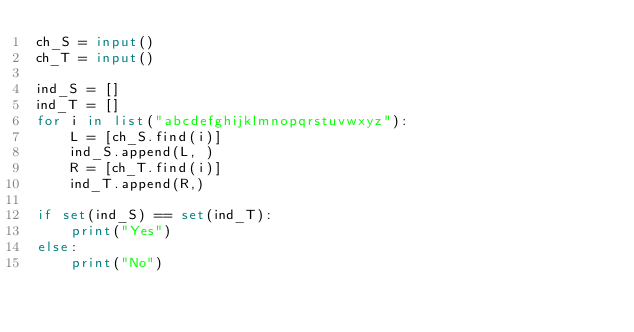Convert code to text. <code><loc_0><loc_0><loc_500><loc_500><_Python_>ch_S = input()
ch_T = input()

ind_S = []
ind_T = []
for i in list("abcdefghijklmnopqrstuvwxyz"):
    L = [ch_S.find(i)]
    ind_S.append(L, )
    R = [ch_T.find(i)]
    ind_T.append(R,)

if set(ind_S) == set(ind_T):
    print("Yes")
else:
    print("No")
</code> 